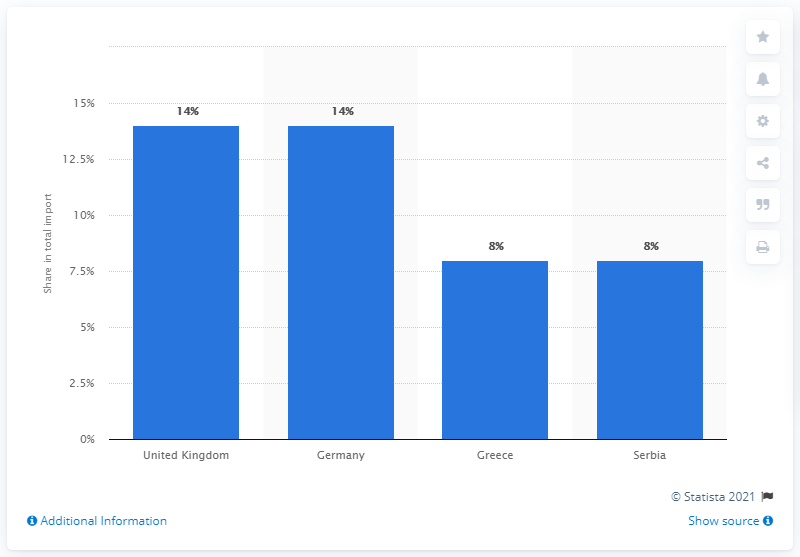Highlight a few significant elements in this photo. In 2019, the United Kingdom was the most significant import partner for North Macedonia. 